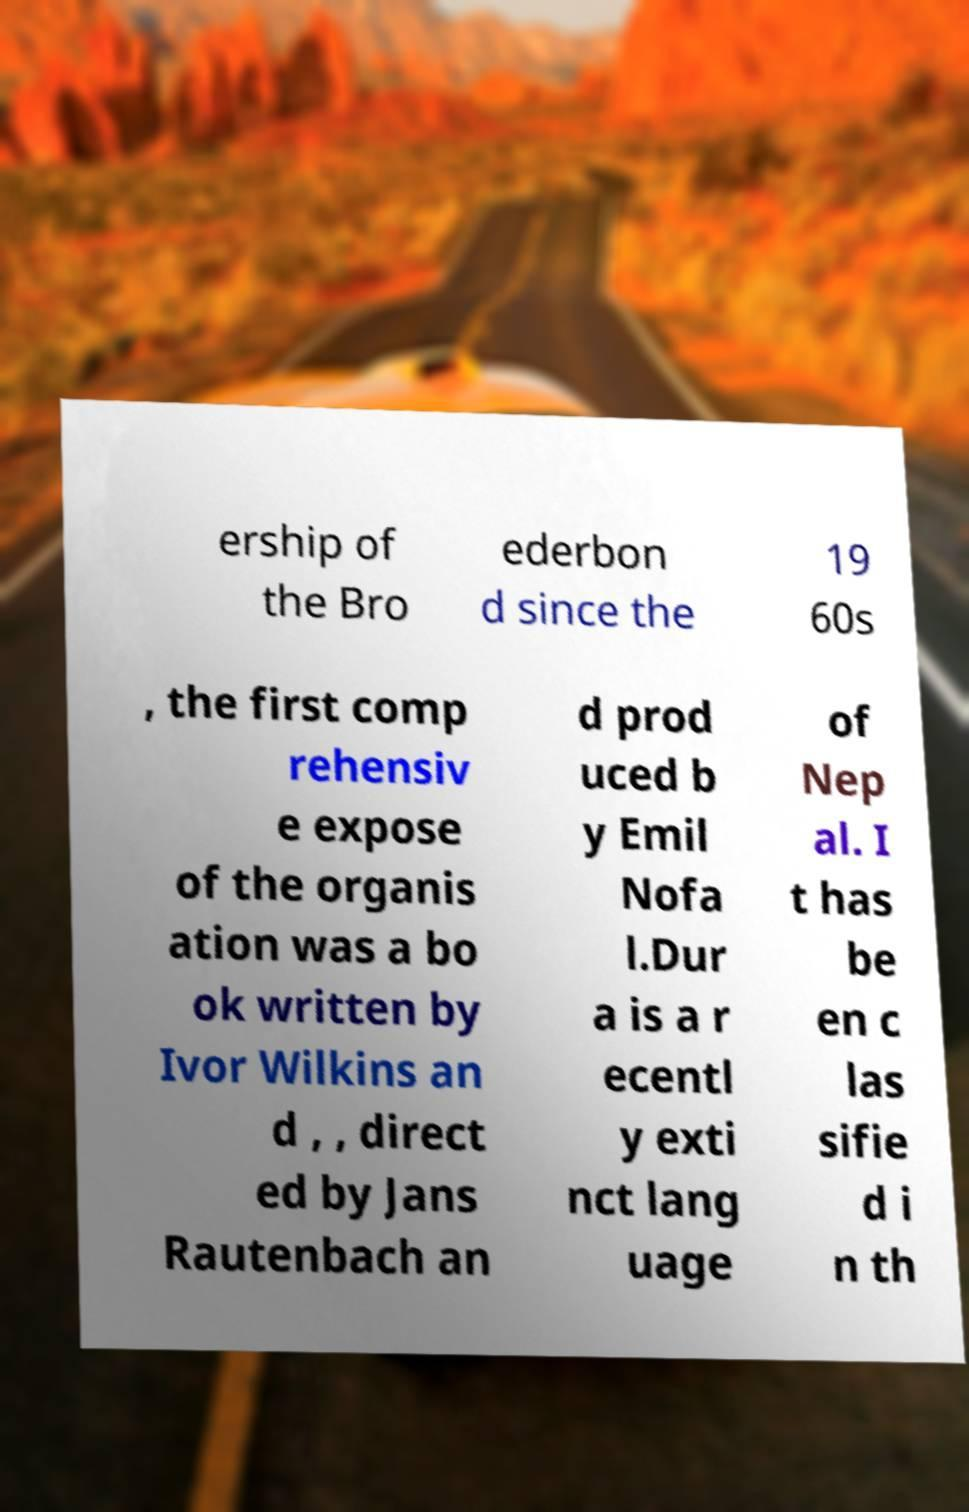Can you accurately transcribe the text from the provided image for me? ership of the Bro ederbon d since the 19 60s , the first comp rehensiv e expose of the organis ation was a bo ok written by Ivor Wilkins an d , , direct ed by Jans Rautenbach an d prod uced b y Emil Nofa l.Dur a is a r ecentl y exti nct lang uage of Nep al. I t has be en c las sifie d i n th 